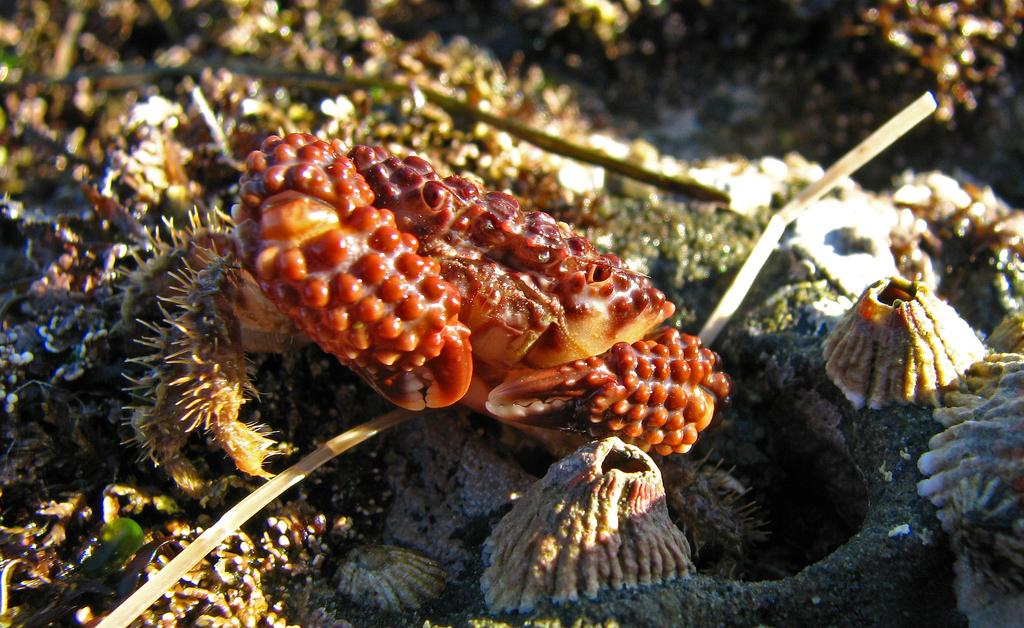What type of objects can be seen in the image? There are shells in the image. What living organism is present in the image? There is an insect in the image. Where is the insect located in the image? The insect is on the surface of something, likely the shells or another surface. What type of rhythm can be heard coming from the shells in the image? There is no sound or rhythm coming from the shells in the image; they are stationary objects. 